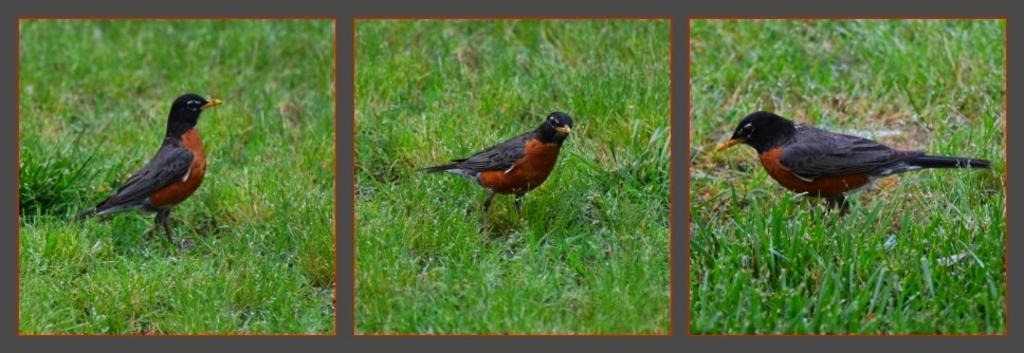Can you describe this image briefly? In this image I can see collage photos of grass and of a bird. I can see colour of this bird is black and brown. 